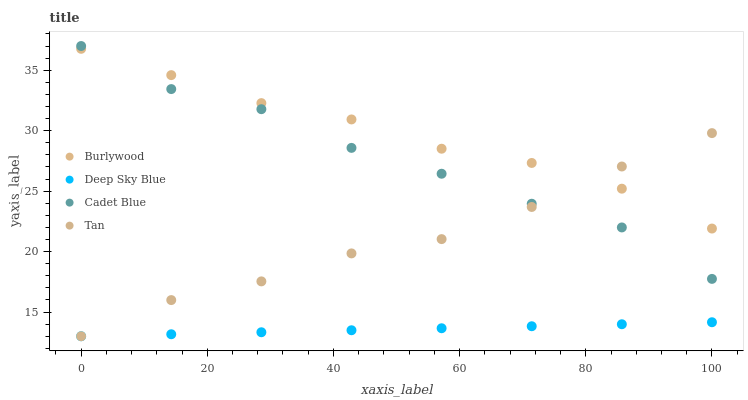Does Deep Sky Blue have the minimum area under the curve?
Answer yes or no. Yes. Does Burlywood have the maximum area under the curve?
Answer yes or no. Yes. Does Tan have the minimum area under the curve?
Answer yes or no. No. Does Tan have the maximum area under the curve?
Answer yes or no. No. Is Deep Sky Blue the smoothest?
Answer yes or no. Yes. Is Cadet Blue the roughest?
Answer yes or no. Yes. Is Tan the smoothest?
Answer yes or no. No. Is Tan the roughest?
Answer yes or no. No. Does Tan have the lowest value?
Answer yes or no. Yes. Does Cadet Blue have the lowest value?
Answer yes or no. No. Does Cadet Blue have the highest value?
Answer yes or no. Yes. Does Tan have the highest value?
Answer yes or no. No. Is Deep Sky Blue less than Cadet Blue?
Answer yes or no. Yes. Is Cadet Blue greater than Deep Sky Blue?
Answer yes or no. Yes. Does Tan intersect Deep Sky Blue?
Answer yes or no. Yes. Is Tan less than Deep Sky Blue?
Answer yes or no. No. Is Tan greater than Deep Sky Blue?
Answer yes or no. No. Does Deep Sky Blue intersect Cadet Blue?
Answer yes or no. No. 